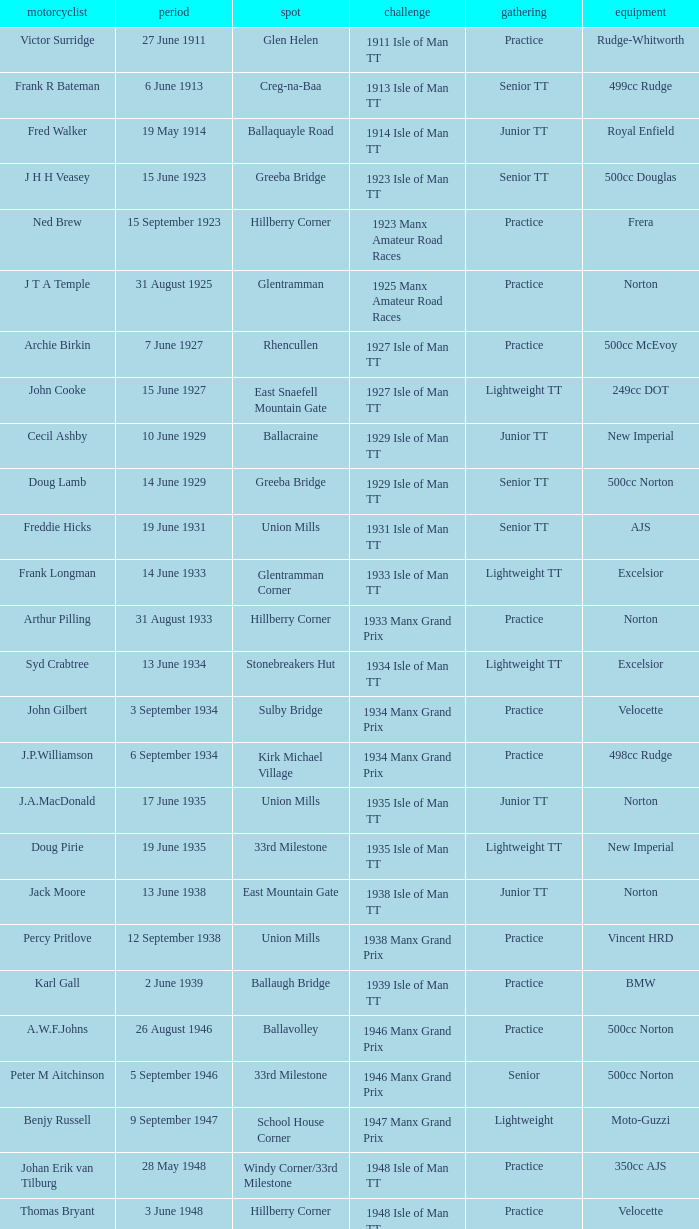What event was Rob Vine riding? Senior TT. 